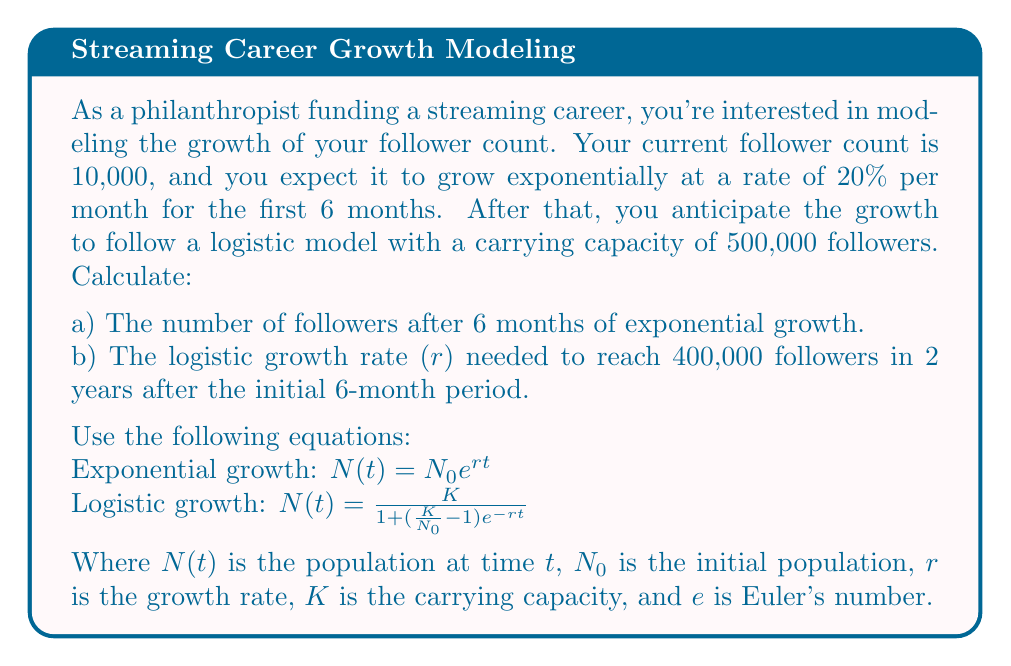Can you solve this math problem? Let's solve this problem step by step:

a) Exponential growth for the first 6 months:
$N_0 = 10,000$ (initial followers)
$r = 0.20$ per month (20% growth rate)
$t = 6$ months

Using the exponential growth equation:
$$N(6) = 10,000 \cdot e^{0.20 \cdot 6}$$
$$N(6) = 10,000 \cdot e^{1.2}$$
$$N(6) = 10,000 \cdot 3.32012$$
$$N(6) = 33,201.17$$

So, after 6 months, there will be approximately 33,201 followers.

b) Logistic growth for the next 2 years:
$N_0 = 33,201$ (followers after 6 months of exponential growth)
$K = 500,000$ (carrying capacity)
$N(t) = 400,000$ (target followers after 2 years)
$t = 24$ months (2 years)

We need to solve for $r$ in the logistic growth equation:

$$400,000 = \frac{500,000}{1 + (\frac{500,000}{33,201} - 1)e^{-24r}}$$

Simplifying:
$$0.8 = \frac{1}{1 + 14.0534e^{-24r}}$$

$$1.25 = 1 + 14.0534e^{-24r}$$
$$0.25 = 14.0534e^{-24r}$$
$$0.0178 = e^{-24r}$$

Taking the natural log of both sides:
$$\ln(0.0178) = -24r$$
$$-4.0284 = -24r$$

Solving for $r$:
$$r = \frac{4.0284}{24} = 0.1678$$

Therefore, the logistic growth rate needed is approximately 0.1678 per month or 16.78% per month.
Answer: a) 33,201 followers
b) r ≈ 0.1678 per month 